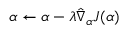Convert formula to latex. <formula><loc_0><loc_0><loc_500><loc_500>\alpha \leftarrow \alpha - \lambda { \hat { \nabla } _ { \alpha } } J ( \alpha )</formula> 